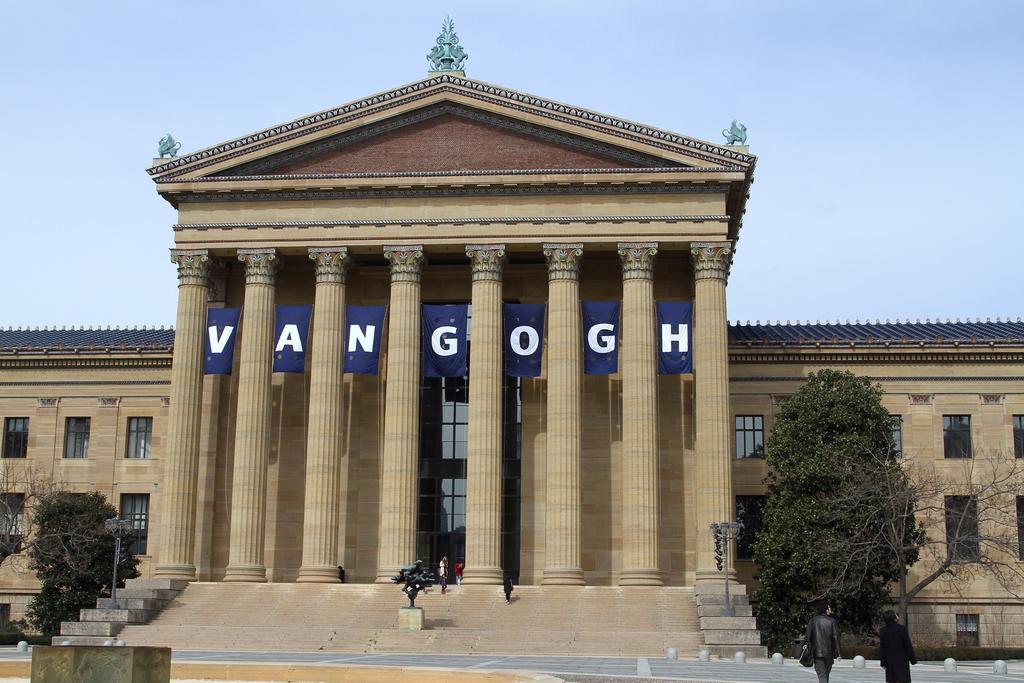Can you describe this image briefly? This picture is clicked outside. In the center we can see the building and we can see the text is attached to the building and there are some trees, poles and some other objects. In the background there is a sky and we can see the sculptures at the top of the building. 